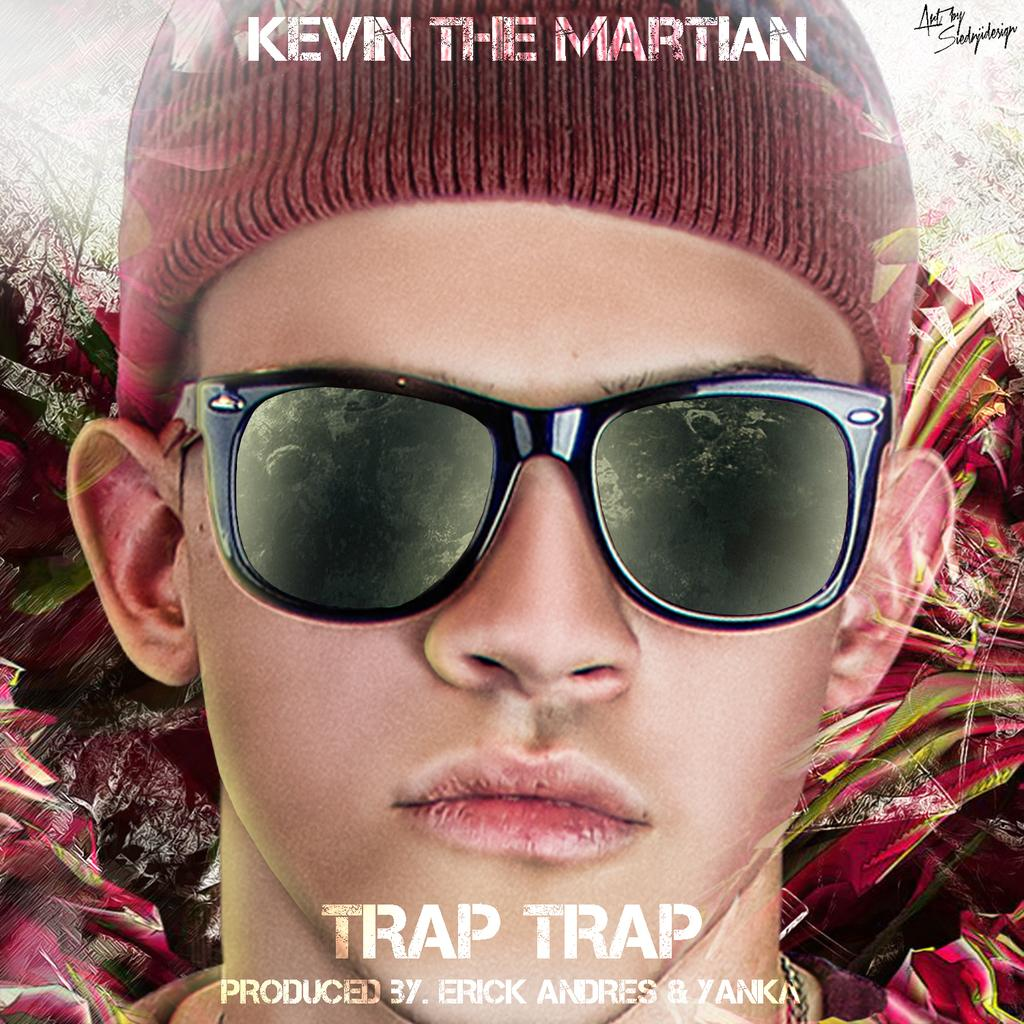Provide a one-sentence caption for the provided image. A closeup ad photo of Kevin the Martian, he is wearing glasses and a tobagan. 